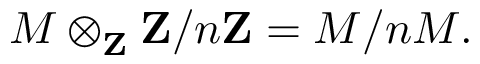<formula> <loc_0><loc_0><loc_500><loc_500>M \otimes _ { Z } Z / n Z = M / n M .</formula> 